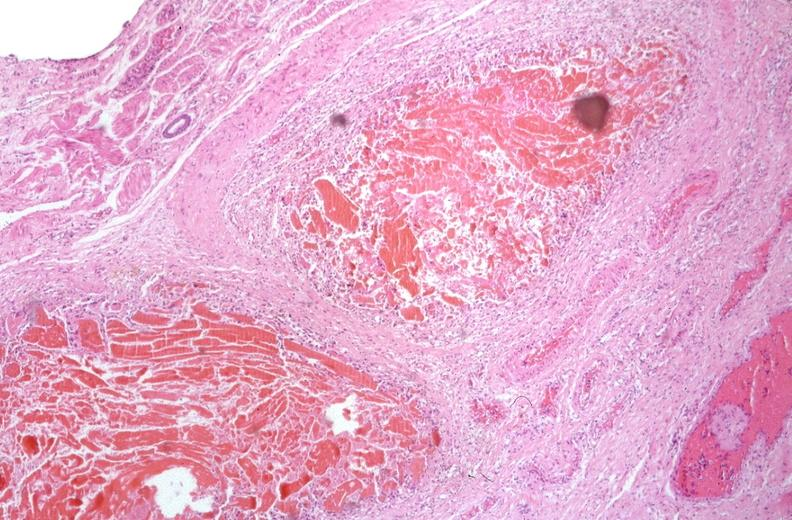what does this image show?
Answer the question using a single word or phrase. Esophogus 